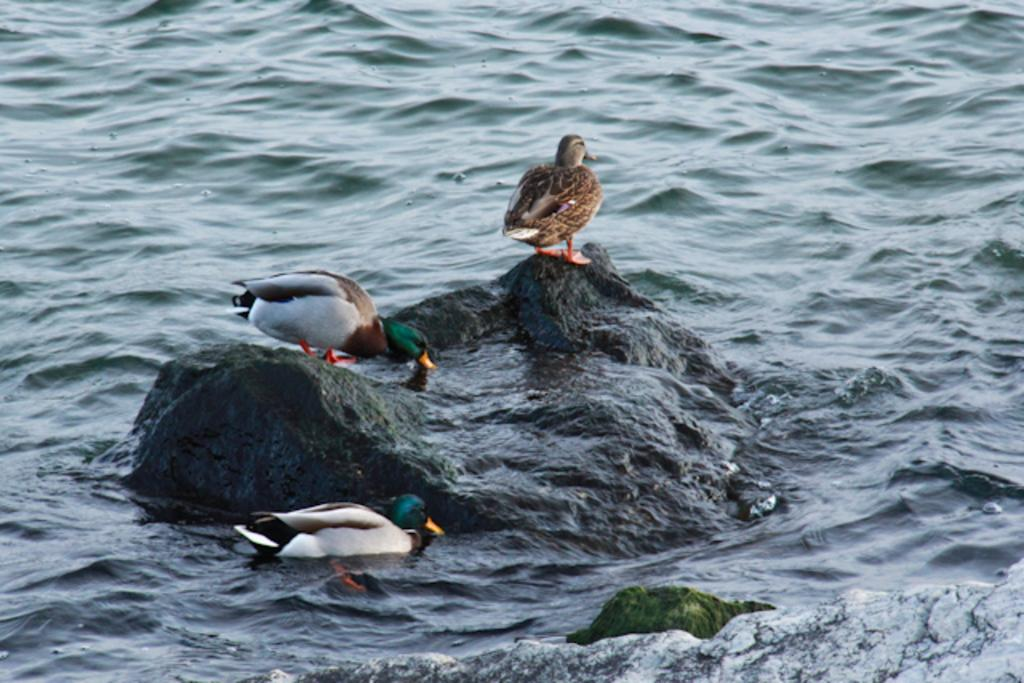What is the main subject in the center of the image? There is a rock in the center of the image. What is on top of the rock in the image? A: There are ducks on the rock. What is the rock in the foreground of the image used for? The rock in the foreground is not mentioned to have a specific purpose in the image. What can be seen surrounding the rock in the image? There is water visible in the image. What type of gun is the mother holding in the image? There is no gun or mother present in the image; it features a rock with ducks and water. 